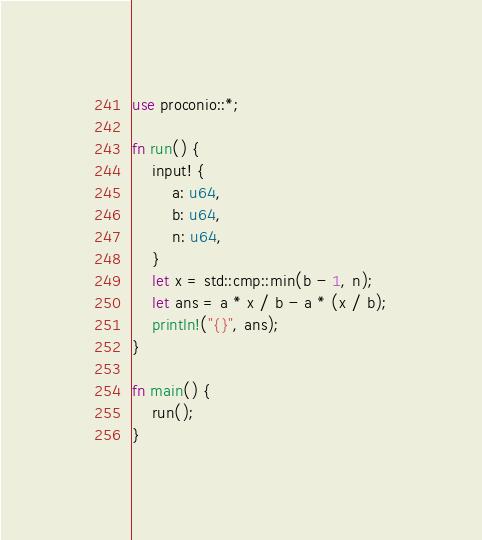<code> <loc_0><loc_0><loc_500><loc_500><_Rust_>use proconio::*;

fn run() {
    input! {
        a: u64,
        b: u64,
        n: u64,
    }
    let x = std::cmp::min(b - 1, n);
    let ans = a * x / b - a * (x / b);
    println!("{}", ans);
}

fn main() {
    run();
}</code> 